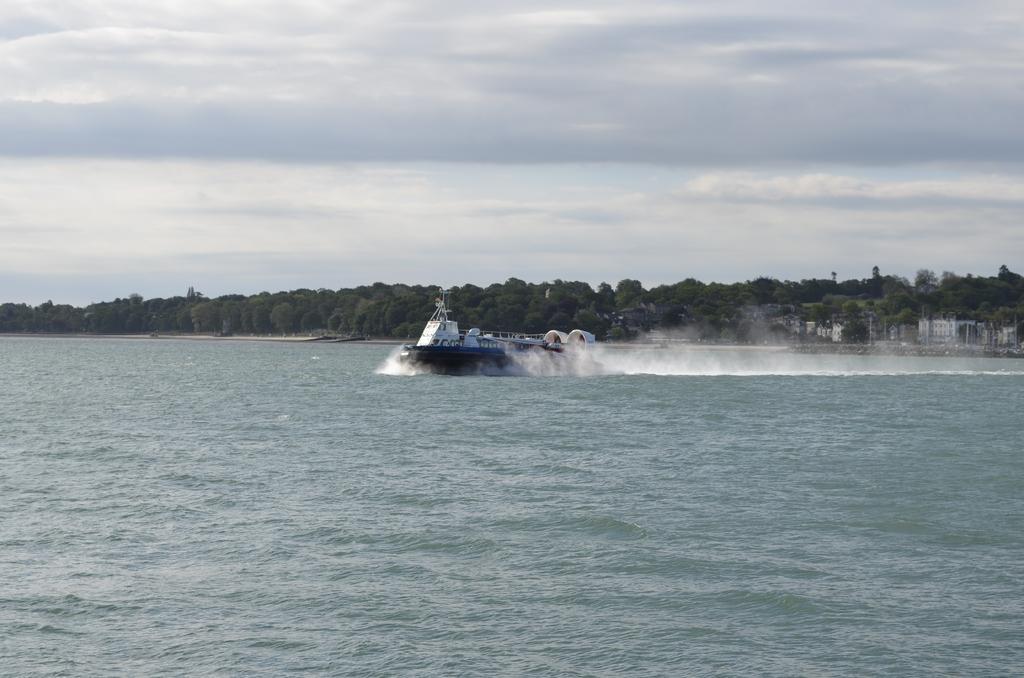Can you describe this image briefly? In this image we can see the boat on the surface of the water. In the background we can see the trees and some buildings. We can also see the sky with the clouds. 